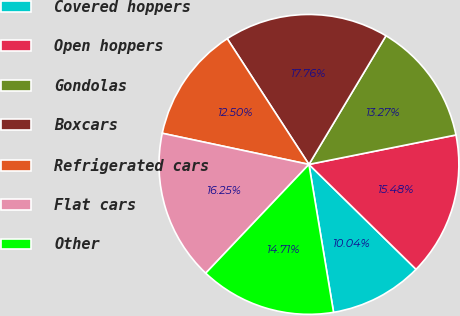<chart> <loc_0><loc_0><loc_500><loc_500><pie_chart><fcel>Covered hoppers<fcel>Open hoppers<fcel>Gondolas<fcel>Boxcars<fcel>Refrigerated cars<fcel>Flat cars<fcel>Other<nl><fcel>10.04%<fcel>15.48%<fcel>13.27%<fcel>17.76%<fcel>12.5%<fcel>16.25%<fcel>14.71%<nl></chart> 